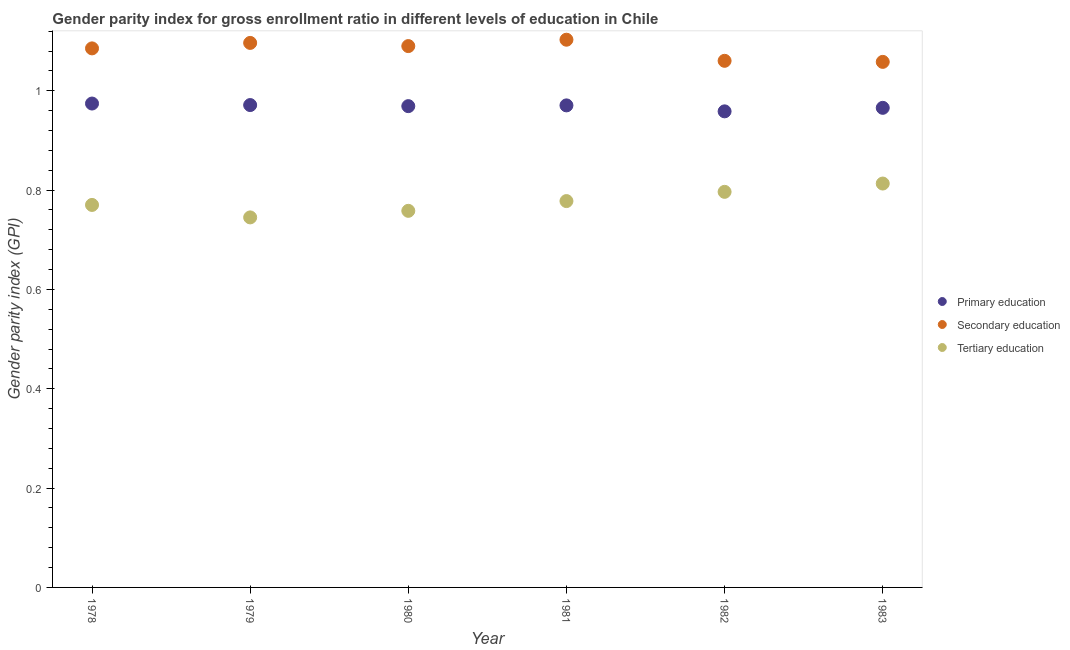How many different coloured dotlines are there?
Give a very brief answer. 3. What is the gender parity index in primary education in 1978?
Provide a succinct answer. 0.97. Across all years, what is the maximum gender parity index in tertiary education?
Provide a succinct answer. 0.81. Across all years, what is the minimum gender parity index in tertiary education?
Your response must be concise. 0.75. What is the total gender parity index in primary education in the graph?
Offer a terse response. 5.81. What is the difference between the gender parity index in primary education in 1980 and that in 1982?
Your answer should be compact. 0.01. What is the difference between the gender parity index in secondary education in 1978 and the gender parity index in primary education in 1980?
Ensure brevity in your answer.  0.12. What is the average gender parity index in secondary education per year?
Offer a terse response. 1.08. In the year 1978, what is the difference between the gender parity index in secondary education and gender parity index in tertiary education?
Ensure brevity in your answer.  0.32. What is the ratio of the gender parity index in primary education in 1980 to that in 1983?
Your answer should be compact. 1. What is the difference between the highest and the second highest gender parity index in primary education?
Your answer should be compact. 0. What is the difference between the highest and the lowest gender parity index in primary education?
Offer a very short reply. 0.02. In how many years, is the gender parity index in tertiary education greater than the average gender parity index in tertiary education taken over all years?
Provide a short and direct response. 3. Is the sum of the gender parity index in primary education in 1980 and 1983 greater than the maximum gender parity index in secondary education across all years?
Your response must be concise. Yes. Does the gender parity index in secondary education monotonically increase over the years?
Give a very brief answer. No. Are the values on the major ticks of Y-axis written in scientific E-notation?
Offer a terse response. No. Does the graph contain any zero values?
Offer a very short reply. No. Where does the legend appear in the graph?
Your response must be concise. Center right. How many legend labels are there?
Make the answer very short. 3. How are the legend labels stacked?
Offer a very short reply. Vertical. What is the title of the graph?
Your answer should be very brief. Gender parity index for gross enrollment ratio in different levels of education in Chile. What is the label or title of the Y-axis?
Offer a very short reply. Gender parity index (GPI). What is the Gender parity index (GPI) in Primary education in 1978?
Make the answer very short. 0.97. What is the Gender parity index (GPI) of Secondary education in 1978?
Your answer should be very brief. 1.09. What is the Gender parity index (GPI) of Tertiary education in 1978?
Provide a succinct answer. 0.77. What is the Gender parity index (GPI) in Primary education in 1979?
Keep it short and to the point. 0.97. What is the Gender parity index (GPI) in Secondary education in 1979?
Give a very brief answer. 1.1. What is the Gender parity index (GPI) of Tertiary education in 1979?
Your answer should be compact. 0.75. What is the Gender parity index (GPI) of Primary education in 1980?
Your answer should be compact. 0.97. What is the Gender parity index (GPI) in Secondary education in 1980?
Offer a very short reply. 1.09. What is the Gender parity index (GPI) of Tertiary education in 1980?
Your answer should be very brief. 0.76. What is the Gender parity index (GPI) in Primary education in 1981?
Give a very brief answer. 0.97. What is the Gender parity index (GPI) of Secondary education in 1981?
Your answer should be compact. 1.1. What is the Gender parity index (GPI) in Tertiary education in 1981?
Keep it short and to the point. 0.78. What is the Gender parity index (GPI) of Primary education in 1982?
Provide a short and direct response. 0.96. What is the Gender parity index (GPI) in Secondary education in 1982?
Keep it short and to the point. 1.06. What is the Gender parity index (GPI) of Tertiary education in 1982?
Offer a very short reply. 0.8. What is the Gender parity index (GPI) of Primary education in 1983?
Your answer should be very brief. 0.97. What is the Gender parity index (GPI) in Secondary education in 1983?
Your answer should be compact. 1.06. What is the Gender parity index (GPI) in Tertiary education in 1983?
Your answer should be very brief. 0.81. Across all years, what is the maximum Gender parity index (GPI) in Primary education?
Your answer should be very brief. 0.97. Across all years, what is the maximum Gender parity index (GPI) of Secondary education?
Ensure brevity in your answer.  1.1. Across all years, what is the maximum Gender parity index (GPI) of Tertiary education?
Ensure brevity in your answer.  0.81. Across all years, what is the minimum Gender parity index (GPI) in Primary education?
Ensure brevity in your answer.  0.96. Across all years, what is the minimum Gender parity index (GPI) in Secondary education?
Offer a very short reply. 1.06. Across all years, what is the minimum Gender parity index (GPI) in Tertiary education?
Ensure brevity in your answer.  0.75. What is the total Gender parity index (GPI) of Primary education in the graph?
Your response must be concise. 5.81. What is the total Gender parity index (GPI) in Secondary education in the graph?
Offer a terse response. 6.49. What is the total Gender parity index (GPI) in Tertiary education in the graph?
Your answer should be very brief. 4.66. What is the difference between the Gender parity index (GPI) of Primary education in 1978 and that in 1979?
Offer a terse response. 0. What is the difference between the Gender parity index (GPI) of Secondary education in 1978 and that in 1979?
Your response must be concise. -0.01. What is the difference between the Gender parity index (GPI) of Tertiary education in 1978 and that in 1979?
Your answer should be very brief. 0.03. What is the difference between the Gender parity index (GPI) in Primary education in 1978 and that in 1980?
Provide a succinct answer. 0.01. What is the difference between the Gender parity index (GPI) in Secondary education in 1978 and that in 1980?
Offer a terse response. -0. What is the difference between the Gender parity index (GPI) in Tertiary education in 1978 and that in 1980?
Your answer should be very brief. 0.01. What is the difference between the Gender parity index (GPI) in Primary education in 1978 and that in 1981?
Make the answer very short. 0. What is the difference between the Gender parity index (GPI) of Secondary education in 1978 and that in 1981?
Ensure brevity in your answer.  -0.02. What is the difference between the Gender parity index (GPI) of Tertiary education in 1978 and that in 1981?
Provide a short and direct response. -0.01. What is the difference between the Gender parity index (GPI) of Primary education in 1978 and that in 1982?
Keep it short and to the point. 0.02. What is the difference between the Gender parity index (GPI) in Secondary education in 1978 and that in 1982?
Keep it short and to the point. 0.03. What is the difference between the Gender parity index (GPI) in Tertiary education in 1978 and that in 1982?
Provide a short and direct response. -0.03. What is the difference between the Gender parity index (GPI) in Primary education in 1978 and that in 1983?
Provide a succinct answer. 0.01. What is the difference between the Gender parity index (GPI) in Secondary education in 1978 and that in 1983?
Offer a terse response. 0.03. What is the difference between the Gender parity index (GPI) in Tertiary education in 1978 and that in 1983?
Your answer should be compact. -0.04. What is the difference between the Gender parity index (GPI) in Primary education in 1979 and that in 1980?
Provide a short and direct response. 0. What is the difference between the Gender parity index (GPI) in Secondary education in 1979 and that in 1980?
Give a very brief answer. 0.01. What is the difference between the Gender parity index (GPI) of Tertiary education in 1979 and that in 1980?
Offer a terse response. -0.01. What is the difference between the Gender parity index (GPI) of Primary education in 1979 and that in 1981?
Offer a very short reply. 0. What is the difference between the Gender parity index (GPI) in Secondary education in 1979 and that in 1981?
Your response must be concise. -0.01. What is the difference between the Gender parity index (GPI) of Tertiary education in 1979 and that in 1981?
Your answer should be compact. -0.03. What is the difference between the Gender parity index (GPI) of Primary education in 1979 and that in 1982?
Offer a very short reply. 0.01. What is the difference between the Gender parity index (GPI) in Secondary education in 1979 and that in 1982?
Ensure brevity in your answer.  0.04. What is the difference between the Gender parity index (GPI) of Tertiary education in 1979 and that in 1982?
Offer a very short reply. -0.05. What is the difference between the Gender parity index (GPI) in Primary education in 1979 and that in 1983?
Make the answer very short. 0.01. What is the difference between the Gender parity index (GPI) in Secondary education in 1979 and that in 1983?
Give a very brief answer. 0.04. What is the difference between the Gender parity index (GPI) in Tertiary education in 1979 and that in 1983?
Make the answer very short. -0.07. What is the difference between the Gender parity index (GPI) in Primary education in 1980 and that in 1981?
Keep it short and to the point. -0. What is the difference between the Gender parity index (GPI) in Secondary education in 1980 and that in 1981?
Your answer should be compact. -0.01. What is the difference between the Gender parity index (GPI) of Tertiary education in 1980 and that in 1981?
Make the answer very short. -0.02. What is the difference between the Gender parity index (GPI) in Primary education in 1980 and that in 1982?
Offer a terse response. 0.01. What is the difference between the Gender parity index (GPI) in Secondary education in 1980 and that in 1982?
Make the answer very short. 0.03. What is the difference between the Gender parity index (GPI) of Tertiary education in 1980 and that in 1982?
Your answer should be very brief. -0.04. What is the difference between the Gender parity index (GPI) in Primary education in 1980 and that in 1983?
Provide a short and direct response. 0. What is the difference between the Gender parity index (GPI) of Secondary education in 1980 and that in 1983?
Offer a terse response. 0.03. What is the difference between the Gender parity index (GPI) of Tertiary education in 1980 and that in 1983?
Offer a very short reply. -0.06. What is the difference between the Gender parity index (GPI) in Primary education in 1981 and that in 1982?
Provide a short and direct response. 0.01. What is the difference between the Gender parity index (GPI) in Secondary education in 1981 and that in 1982?
Offer a very short reply. 0.04. What is the difference between the Gender parity index (GPI) of Tertiary education in 1981 and that in 1982?
Make the answer very short. -0.02. What is the difference between the Gender parity index (GPI) of Primary education in 1981 and that in 1983?
Provide a succinct answer. 0. What is the difference between the Gender parity index (GPI) of Secondary education in 1981 and that in 1983?
Ensure brevity in your answer.  0.04. What is the difference between the Gender parity index (GPI) in Tertiary education in 1981 and that in 1983?
Make the answer very short. -0.04. What is the difference between the Gender parity index (GPI) in Primary education in 1982 and that in 1983?
Give a very brief answer. -0.01. What is the difference between the Gender parity index (GPI) of Secondary education in 1982 and that in 1983?
Ensure brevity in your answer.  0. What is the difference between the Gender parity index (GPI) in Tertiary education in 1982 and that in 1983?
Keep it short and to the point. -0.02. What is the difference between the Gender parity index (GPI) of Primary education in 1978 and the Gender parity index (GPI) of Secondary education in 1979?
Make the answer very short. -0.12. What is the difference between the Gender parity index (GPI) in Primary education in 1978 and the Gender parity index (GPI) in Tertiary education in 1979?
Provide a short and direct response. 0.23. What is the difference between the Gender parity index (GPI) of Secondary education in 1978 and the Gender parity index (GPI) of Tertiary education in 1979?
Offer a terse response. 0.34. What is the difference between the Gender parity index (GPI) of Primary education in 1978 and the Gender parity index (GPI) of Secondary education in 1980?
Provide a succinct answer. -0.12. What is the difference between the Gender parity index (GPI) of Primary education in 1978 and the Gender parity index (GPI) of Tertiary education in 1980?
Make the answer very short. 0.22. What is the difference between the Gender parity index (GPI) in Secondary education in 1978 and the Gender parity index (GPI) in Tertiary education in 1980?
Your answer should be compact. 0.33. What is the difference between the Gender parity index (GPI) in Primary education in 1978 and the Gender parity index (GPI) in Secondary education in 1981?
Keep it short and to the point. -0.13. What is the difference between the Gender parity index (GPI) in Primary education in 1978 and the Gender parity index (GPI) in Tertiary education in 1981?
Give a very brief answer. 0.2. What is the difference between the Gender parity index (GPI) of Secondary education in 1978 and the Gender parity index (GPI) of Tertiary education in 1981?
Give a very brief answer. 0.31. What is the difference between the Gender parity index (GPI) of Primary education in 1978 and the Gender parity index (GPI) of Secondary education in 1982?
Your answer should be compact. -0.09. What is the difference between the Gender parity index (GPI) in Primary education in 1978 and the Gender parity index (GPI) in Tertiary education in 1982?
Offer a terse response. 0.18. What is the difference between the Gender parity index (GPI) of Secondary education in 1978 and the Gender parity index (GPI) of Tertiary education in 1982?
Provide a short and direct response. 0.29. What is the difference between the Gender parity index (GPI) in Primary education in 1978 and the Gender parity index (GPI) in Secondary education in 1983?
Ensure brevity in your answer.  -0.08. What is the difference between the Gender parity index (GPI) of Primary education in 1978 and the Gender parity index (GPI) of Tertiary education in 1983?
Give a very brief answer. 0.16. What is the difference between the Gender parity index (GPI) in Secondary education in 1978 and the Gender parity index (GPI) in Tertiary education in 1983?
Ensure brevity in your answer.  0.27. What is the difference between the Gender parity index (GPI) in Primary education in 1979 and the Gender parity index (GPI) in Secondary education in 1980?
Give a very brief answer. -0.12. What is the difference between the Gender parity index (GPI) in Primary education in 1979 and the Gender parity index (GPI) in Tertiary education in 1980?
Your answer should be compact. 0.21. What is the difference between the Gender parity index (GPI) in Secondary education in 1979 and the Gender parity index (GPI) in Tertiary education in 1980?
Offer a very short reply. 0.34. What is the difference between the Gender parity index (GPI) of Primary education in 1979 and the Gender parity index (GPI) of Secondary education in 1981?
Provide a succinct answer. -0.13. What is the difference between the Gender parity index (GPI) of Primary education in 1979 and the Gender parity index (GPI) of Tertiary education in 1981?
Your answer should be very brief. 0.19. What is the difference between the Gender parity index (GPI) in Secondary education in 1979 and the Gender parity index (GPI) in Tertiary education in 1981?
Provide a succinct answer. 0.32. What is the difference between the Gender parity index (GPI) in Primary education in 1979 and the Gender parity index (GPI) in Secondary education in 1982?
Give a very brief answer. -0.09. What is the difference between the Gender parity index (GPI) in Primary education in 1979 and the Gender parity index (GPI) in Tertiary education in 1982?
Your answer should be very brief. 0.17. What is the difference between the Gender parity index (GPI) of Secondary education in 1979 and the Gender parity index (GPI) of Tertiary education in 1982?
Your answer should be very brief. 0.3. What is the difference between the Gender parity index (GPI) of Primary education in 1979 and the Gender parity index (GPI) of Secondary education in 1983?
Your answer should be very brief. -0.09. What is the difference between the Gender parity index (GPI) in Primary education in 1979 and the Gender parity index (GPI) in Tertiary education in 1983?
Offer a very short reply. 0.16. What is the difference between the Gender parity index (GPI) in Secondary education in 1979 and the Gender parity index (GPI) in Tertiary education in 1983?
Provide a short and direct response. 0.28. What is the difference between the Gender parity index (GPI) of Primary education in 1980 and the Gender parity index (GPI) of Secondary education in 1981?
Your answer should be very brief. -0.13. What is the difference between the Gender parity index (GPI) of Primary education in 1980 and the Gender parity index (GPI) of Tertiary education in 1981?
Offer a very short reply. 0.19. What is the difference between the Gender parity index (GPI) in Secondary education in 1980 and the Gender parity index (GPI) in Tertiary education in 1981?
Offer a very short reply. 0.31. What is the difference between the Gender parity index (GPI) in Primary education in 1980 and the Gender parity index (GPI) in Secondary education in 1982?
Make the answer very short. -0.09. What is the difference between the Gender parity index (GPI) in Primary education in 1980 and the Gender parity index (GPI) in Tertiary education in 1982?
Provide a succinct answer. 0.17. What is the difference between the Gender parity index (GPI) in Secondary education in 1980 and the Gender parity index (GPI) in Tertiary education in 1982?
Keep it short and to the point. 0.29. What is the difference between the Gender parity index (GPI) in Primary education in 1980 and the Gender parity index (GPI) in Secondary education in 1983?
Provide a short and direct response. -0.09. What is the difference between the Gender parity index (GPI) of Primary education in 1980 and the Gender parity index (GPI) of Tertiary education in 1983?
Keep it short and to the point. 0.16. What is the difference between the Gender parity index (GPI) of Secondary education in 1980 and the Gender parity index (GPI) of Tertiary education in 1983?
Provide a succinct answer. 0.28. What is the difference between the Gender parity index (GPI) in Primary education in 1981 and the Gender parity index (GPI) in Secondary education in 1982?
Offer a very short reply. -0.09. What is the difference between the Gender parity index (GPI) in Primary education in 1981 and the Gender parity index (GPI) in Tertiary education in 1982?
Your response must be concise. 0.17. What is the difference between the Gender parity index (GPI) in Secondary education in 1981 and the Gender parity index (GPI) in Tertiary education in 1982?
Your answer should be compact. 0.31. What is the difference between the Gender parity index (GPI) in Primary education in 1981 and the Gender parity index (GPI) in Secondary education in 1983?
Ensure brevity in your answer.  -0.09. What is the difference between the Gender parity index (GPI) in Primary education in 1981 and the Gender parity index (GPI) in Tertiary education in 1983?
Provide a short and direct response. 0.16. What is the difference between the Gender parity index (GPI) in Secondary education in 1981 and the Gender parity index (GPI) in Tertiary education in 1983?
Offer a terse response. 0.29. What is the difference between the Gender parity index (GPI) of Primary education in 1982 and the Gender parity index (GPI) of Secondary education in 1983?
Ensure brevity in your answer.  -0.1. What is the difference between the Gender parity index (GPI) in Primary education in 1982 and the Gender parity index (GPI) in Tertiary education in 1983?
Ensure brevity in your answer.  0.15. What is the difference between the Gender parity index (GPI) in Secondary education in 1982 and the Gender parity index (GPI) in Tertiary education in 1983?
Give a very brief answer. 0.25. What is the average Gender parity index (GPI) of Primary education per year?
Provide a succinct answer. 0.97. What is the average Gender parity index (GPI) of Secondary education per year?
Offer a terse response. 1.08. What is the average Gender parity index (GPI) in Tertiary education per year?
Provide a succinct answer. 0.78. In the year 1978, what is the difference between the Gender parity index (GPI) in Primary education and Gender parity index (GPI) in Secondary education?
Ensure brevity in your answer.  -0.11. In the year 1978, what is the difference between the Gender parity index (GPI) in Primary education and Gender parity index (GPI) in Tertiary education?
Keep it short and to the point. 0.2. In the year 1978, what is the difference between the Gender parity index (GPI) in Secondary education and Gender parity index (GPI) in Tertiary education?
Your response must be concise. 0.32. In the year 1979, what is the difference between the Gender parity index (GPI) of Primary education and Gender parity index (GPI) of Secondary education?
Provide a short and direct response. -0.13. In the year 1979, what is the difference between the Gender parity index (GPI) in Primary education and Gender parity index (GPI) in Tertiary education?
Make the answer very short. 0.23. In the year 1979, what is the difference between the Gender parity index (GPI) in Secondary education and Gender parity index (GPI) in Tertiary education?
Make the answer very short. 0.35. In the year 1980, what is the difference between the Gender parity index (GPI) of Primary education and Gender parity index (GPI) of Secondary education?
Provide a succinct answer. -0.12. In the year 1980, what is the difference between the Gender parity index (GPI) of Primary education and Gender parity index (GPI) of Tertiary education?
Ensure brevity in your answer.  0.21. In the year 1980, what is the difference between the Gender parity index (GPI) in Secondary education and Gender parity index (GPI) in Tertiary education?
Provide a succinct answer. 0.33. In the year 1981, what is the difference between the Gender parity index (GPI) of Primary education and Gender parity index (GPI) of Secondary education?
Ensure brevity in your answer.  -0.13. In the year 1981, what is the difference between the Gender parity index (GPI) in Primary education and Gender parity index (GPI) in Tertiary education?
Offer a terse response. 0.19. In the year 1981, what is the difference between the Gender parity index (GPI) in Secondary education and Gender parity index (GPI) in Tertiary education?
Keep it short and to the point. 0.32. In the year 1982, what is the difference between the Gender parity index (GPI) in Primary education and Gender parity index (GPI) in Secondary education?
Offer a terse response. -0.1. In the year 1982, what is the difference between the Gender parity index (GPI) in Primary education and Gender parity index (GPI) in Tertiary education?
Provide a short and direct response. 0.16. In the year 1982, what is the difference between the Gender parity index (GPI) in Secondary education and Gender parity index (GPI) in Tertiary education?
Your answer should be compact. 0.26. In the year 1983, what is the difference between the Gender parity index (GPI) of Primary education and Gender parity index (GPI) of Secondary education?
Your answer should be compact. -0.09. In the year 1983, what is the difference between the Gender parity index (GPI) in Primary education and Gender parity index (GPI) in Tertiary education?
Make the answer very short. 0.15. In the year 1983, what is the difference between the Gender parity index (GPI) of Secondary education and Gender parity index (GPI) of Tertiary education?
Keep it short and to the point. 0.24. What is the ratio of the Gender parity index (GPI) in Tertiary education in 1978 to that in 1979?
Your answer should be very brief. 1.03. What is the ratio of the Gender parity index (GPI) in Primary education in 1978 to that in 1980?
Provide a succinct answer. 1.01. What is the ratio of the Gender parity index (GPI) in Tertiary education in 1978 to that in 1980?
Give a very brief answer. 1.02. What is the ratio of the Gender parity index (GPI) in Secondary education in 1978 to that in 1981?
Keep it short and to the point. 0.98. What is the ratio of the Gender parity index (GPI) of Primary education in 1978 to that in 1982?
Your answer should be very brief. 1.02. What is the ratio of the Gender parity index (GPI) in Secondary education in 1978 to that in 1982?
Your answer should be compact. 1.02. What is the ratio of the Gender parity index (GPI) of Tertiary education in 1978 to that in 1982?
Give a very brief answer. 0.97. What is the ratio of the Gender parity index (GPI) in Primary education in 1978 to that in 1983?
Make the answer very short. 1.01. What is the ratio of the Gender parity index (GPI) in Secondary education in 1978 to that in 1983?
Keep it short and to the point. 1.03. What is the ratio of the Gender parity index (GPI) in Tertiary education in 1978 to that in 1983?
Your response must be concise. 0.95. What is the ratio of the Gender parity index (GPI) of Secondary education in 1979 to that in 1980?
Offer a very short reply. 1.01. What is the ratio of the Gender parity index (GPI) of Tertiary education in 1979 to that in 1980?
Ensure brevity in your answer.  0.98. What is the ratio of the Gender parity index (GPI) in Primary education in 1979 to that in 1981?
Offer a terse response. 1. What is the ratio of the Gender parity index (GPI) in Secondary education in 1979 to that in 1981?
Your response must be concise. 0.99. What is the ratio of the Gender parity index (GPI) in Tertiary education in 1979 to that in 1981?
Ensure brevity in your answer.  0.96. What is the ratio of the Gender parity index (GPI) in Primary education in 1979 to that in 1982?
Offer a very short reply. 1.01. What is the ratio of the Gender parity index (GPI) in Secondary education in 1979 to that in 1982?
Offer a very short reply. 1.03. What is the ratio of the Gender parity index (GPI) of Tertiary education in 1979 to that in 1982?
Offer a terse response. 0.94. What is the ratio of the Gender parity index (GPI) in Primary education in 1979 to that in 1983?
Your response must be concise. 1.01. What is the ratio of the Gender parity index (GPI) of Secondary education in 1979 to that in 1983?
Provide a succinct answer. 1.04. What is the ratio of the Gender parity index (GPI) in Tertiary education in 1979 to that in 1983?
Give a very brief answer. 0.92. What is the ratio of the Gender parity index (GPI) in Primary education in 1980 to that in 1981?
Make the answer very short. 1. What is the ratio of the Gender parity index (GPI) in Secondary education in 1980 to that in 1981?
Offer a very short reply. 0.99. What is the ratio of the Gender parity index (GPI) in Tertiary education in 1980 to that in 1981?
Provide a succinct answer. 0.97. What is the ratio of the Gender parity index (GPI) of Secondary education in 1980 to that in 1982?
Give a very brief answer. 1.03. What is the ratio of the Gender parity index (GPI) of Secondary education in 1980 to that in 1983?
Provide a succinct answer. 1.03. What is the ratio of the Gender parity index (GPI) in Tertiary education in 1980 to that in 1983?
Give a very brief answer. 0.93. What is the ratio of the Gender parity index (GPI) in Primary education in 1981 to that in 1982?
Provide a succinct answer. 1.01. What is the ratio of the Gender parity index (GPI) of Secondary education in 1981 to that in 1982?
Your response must be concise. 1.04. What is the ratio of the Gender parity index (GPI) in Tertiary education in 1981 to that in 1982?
Provide a succinct answer. 0.98. What is the ratio of the Gender parity index (GPI) in Primary education in 1981 to that in 1983?
Your response must be concise. 1.01. What is the ratio of the Gender parity index (GPI) of Secondary education in 1981 to that in 1983?
Your answer should be very brief. 1.04. What is the ratio of the Gender parity index (GPI) of Tertiary education in 1981 to that in 1983?
Your answer should be very brief. 0.96. What is the ratio of the Gender parity index (GPI) in Primary education in 1982 to that in 1983?
Your response must be concise. 0.99. What is the ratio of the Gender parity index (GPI) in Tertiary education in 1982 to that in 1983?
Give a very brief answer. 0.98. What is the difference between the highest and the second highest Gender parity index (GPI) of Primary education?
Your answer should be compact. 0. What is the difference between the highest and the second highest Gender parity index (GPI) in Secondary education?
Your answer should be very brief. 0.01. What is the difference between the highest and the second highest Gender parity index (GPI) of Tertiary education?
Give a very brief answer. 0.02. What is the difference between the highest and the lowest Gender parity index (GPI) in Primary education?
Provide a succinct answer. 0.02. What is the difference between the highest and the lowest Gender parity index (GPI) in Secondary education?
Provide a short and direct response. 0.04. What is the difference between the highest and the lowest Gender parity index (GPI) in Tertiary education?
Provide a succinct answer. 0.07. 